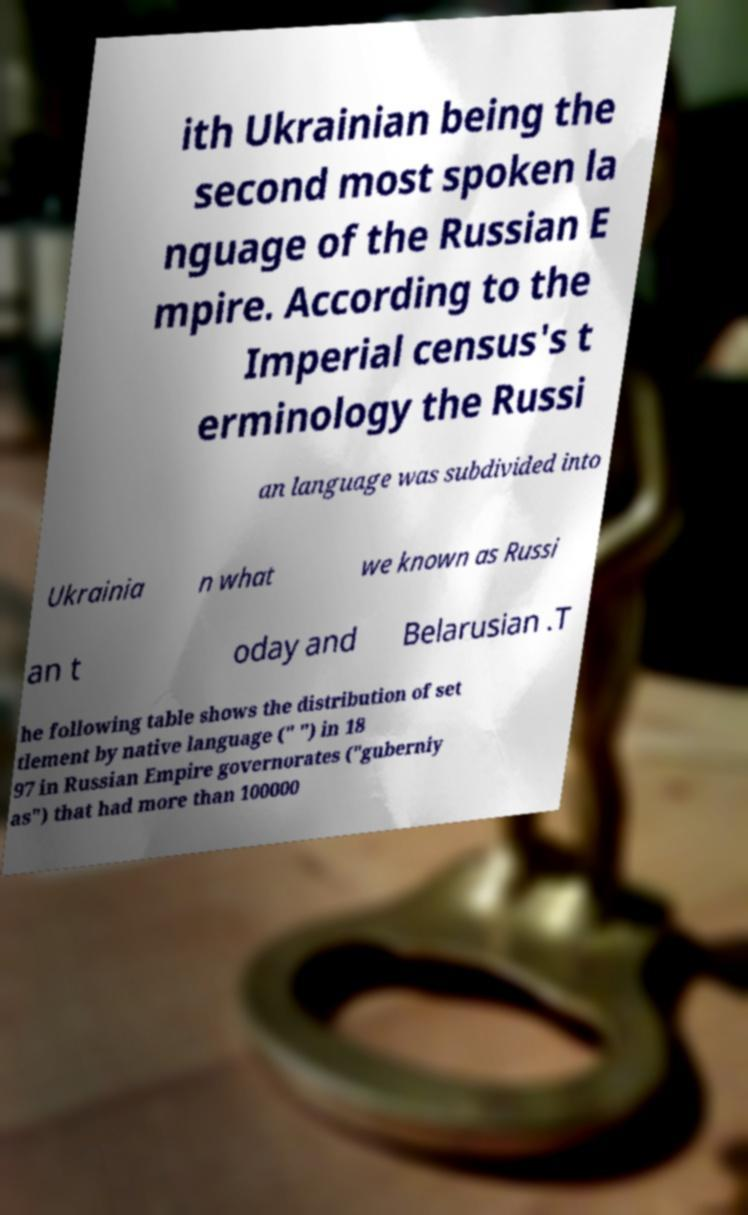For documentation purposes, I need the text within this image transcribed. Could you provide that? ith Ukrainian being the second most spoken la nguage of the Russian E mpire. According to the Imperial census's t erminology the Russi an language was subdivided into Ukrainia n what we known as Russi an t oday and Belarusian .T he following table shows the distribution of set tlement by native language (" ") in 18 97 in Russian Empire governorates ("guberniy as") that had more than 100000 